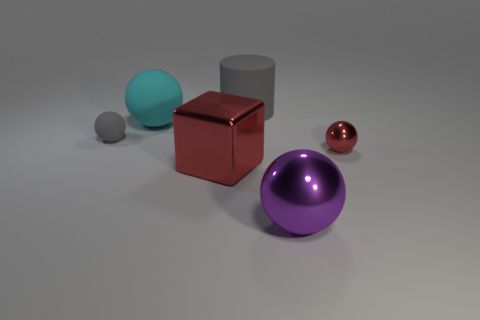What number of things have the same material as the gray ball?
Your answer should be very brief. 2. Do the gray cylinder and the sphere in front of the small red sphere have the same size?
Offer a terse response. Yes. There is a big cylinder that is the same color as the small matte sphere; what material is it?
Your response must be concise. Rubber. What is the size of the gray rubber object that is right of the red shiny thing in front of the tiny ball right of the gray ball?
Make the answer very short. Large. Are there more large cylinders that are right of the small red metallic sphere than cyan spheres left of the large rubber ball?
Offer a terse response. No. There is a large ball on the right side of the big cylinder; what number of gray balls are to the right of it?
Provide a short and direct response. 0. Are there any other cylinders of the same color as the rubber cylinder?
Give a very brief answer. No. Is the size of the matte cylinder the same as the purple sphere?
Make the answer very short. Yes. Do the tiny matte sphere and the cylinder have the same color?
Provide a succinct answer. Yes. The red object that is in front of the red metallic thing on the right side of the purple thing is made of what material?
Make the answer very short. Metal. 